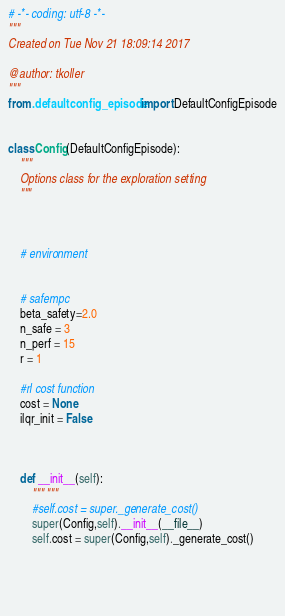<code> <loc_0><loc_0><loc_500><loc_500><_Python_># -*- coding: utf-8 -*-
"""
Created on Tue Nov 21 18:09:14 2017

@author: tkoller
"""
from .defaultconfig_episode import DefaultConfigEpisode


class Config(DefaultConfigEpisode):
    """
    Options class for the exploration setting
    """


    
    # environment

    
    # safempc
    beta_safety=2.0
    n_safe = 3
    n_perf = 15
    r = 1

    #rl cost function
    cost = None
    ilqr_init = False



    def __init__(self):
        """ """
        #self.cost = super._generate_cost()
        super(Config,self).__init__(__file__)
        self.cost = super(Config,self)._generate_cost()
        
            
            
    
</code> 